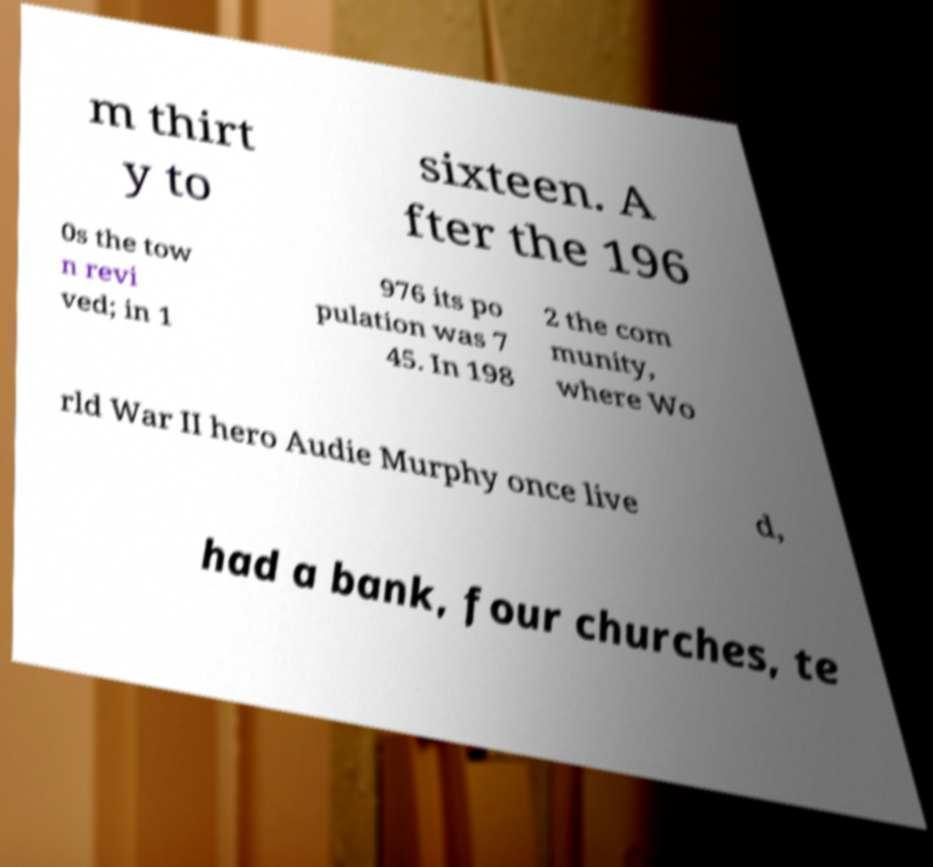Could you extract and type out the text from this image? m thirt y to sixteen. A fter the 196 0s the tow n revi ved; in 1 976 its po pulation was 7 45. In 198 2 the com munity, where Wo rld War II hero Audie Murphy once live d, had a bank, four churches, te 